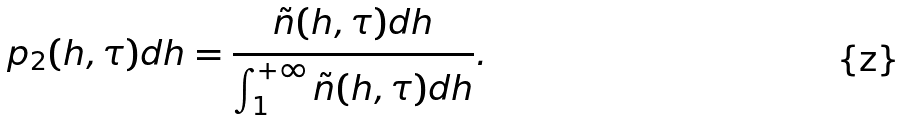Convert formula to latex. <formula><loc_0><loc_0><loc_500><loc_500>p _ { 2 } ( h , \tau ) d h = \frac { \tilde { n } ( h , \tau ) d h } { \int _ { 1 } ^ { + \infty } \tilde { n } ( h , \tau ) d h } .</formula> 